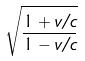Convert formula to latex. <formula><loc_0><loc_0><loc_500><loc_500>\sqrt { \frac { 1 + v / c } { 1 - v / c } }</formula> 